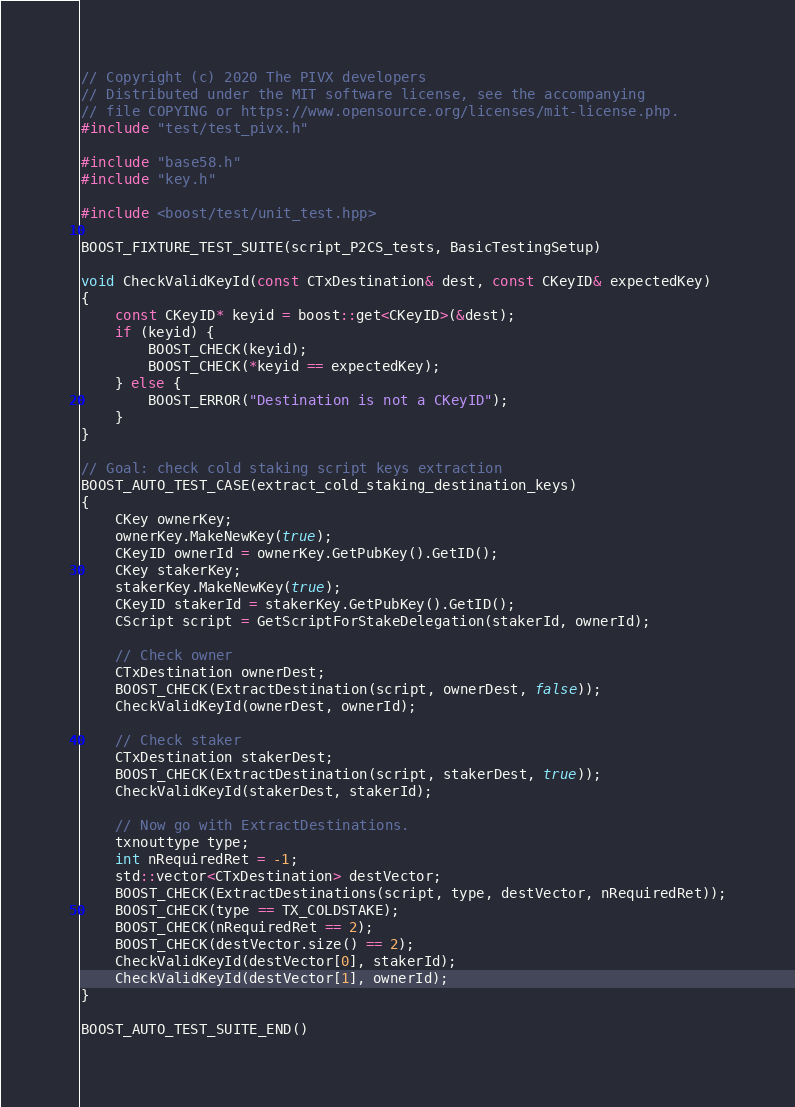<code> <loc_0><loc_0><loc_500><loc_500><_C++_>// Copyright (c) 2020 The PIVX developers
// Distributed under the MIT software license, see the accompanying
// file COPYING or https://www.opensource.org/licenses/mit-license.php.
#include "test/test_pivx.h"

#include "base58.h"
#include "key.h"

#include <boost/test/unit_test.hpp>

BOOST_FIXTURE_TEST_SUITE(script_P2CS_tests, BasicTestingSetup)

void CheckValidKeyId(const CTxDestination& dest, const CKeyID& expectedKey)
{
    const CKeyID* keyid = boost::get<CKeyID>(&dest);
    if (keyid) {
        BOOST_CHECK(keyid);
        BOOST_CHECK(*keyid == expectedKey);
    } else {
        BOOST_ERROR("Destination is not a CKeyID");
    }
}

// Goal: check cold staking script keys extraction
BOOST_AUTO_TEST_CASE(extract_cold_staking_destination_keys)
{
    CKey ownerKey;
    ownerKey.MakeNewKey(true);
    CKeyID ownerId = ownerKey.GetPubKey().GetID();
    CKey stakerKey;
    stakerKey.MakeNewKey(true);
    CKeyID stakerId = stakerKey.GetPubKey().GetID();
    CScript script = GetScriptForStakeDelegation(stakerId, ownerId);

    // Check owner
    CTxDestination ownerDest;
    BOOST_CHECK(ExtractDestination(script, ownerDest, false));
    CheckValidKeyId(ownerDest, ownerId);

    // Check staker
    CTxDestination stakerDest;
    BOOST_CHECK(ExtractDestination(script, stakerDest, true));
    CheckValidKeyId(stakerDest, stakerId);

    // Now go with ExtractDestinations.
    txnouttype type;
    int nRequiredRet = -1;
    std::vector<CTxDestination> destVector;
    BOOST_CHECK(ExtractDestinations(script, type, destVector, nRequiredRet));
    BOOST_CHECK(type == TX_COLDSTAKE);
    BOOST_CHECK(nRequiredRet == 2);
    BOOST_CHECK(destVector.size() == 2);
    CheckValidKeyId(destVector[0], stakerId);
    CheckValidKeyId(destVector[1], ownerId);
}

BOOST_AUTO_TEST_SUITE_END()
</code> 